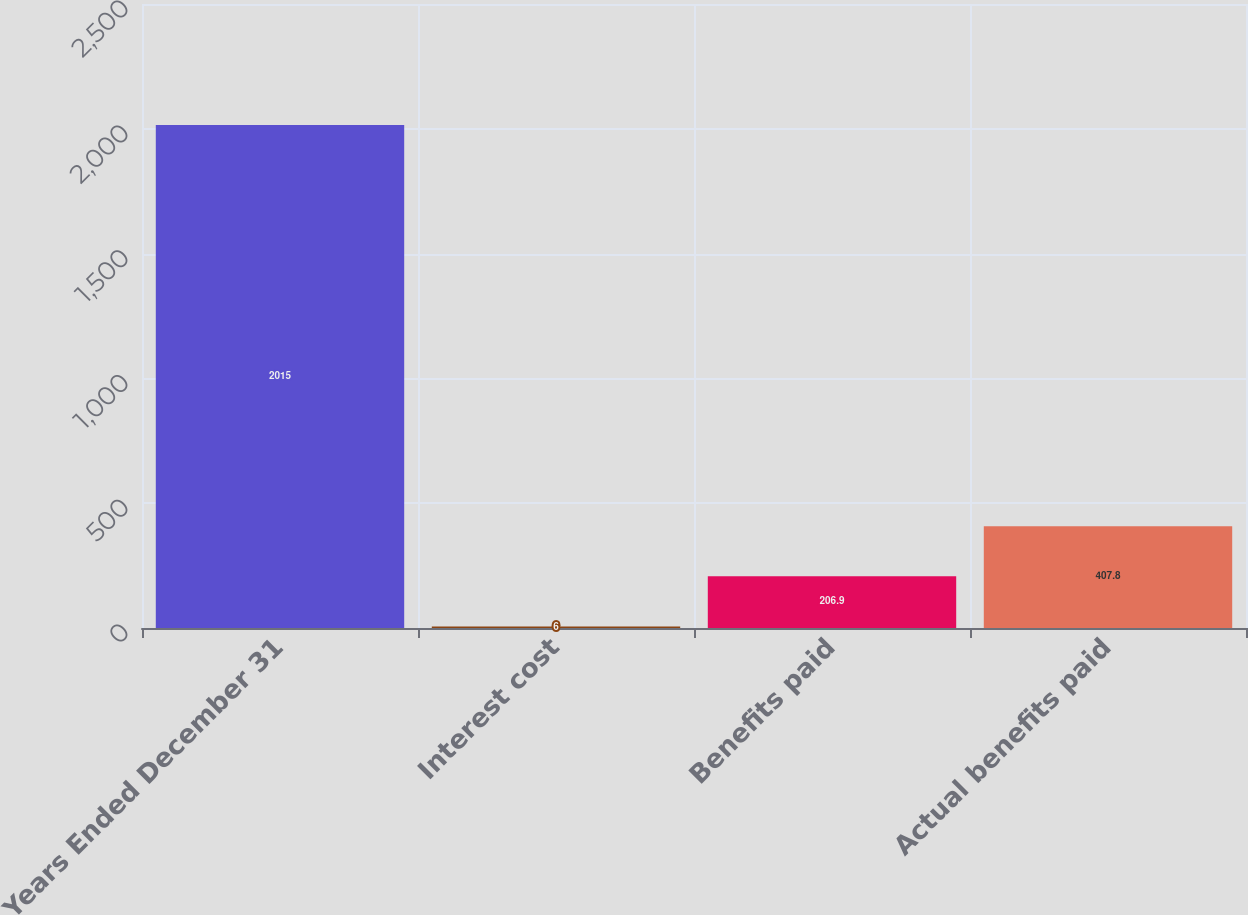<chart> <loc_0><loc_0><loc_500><loc_500><bar_chart><fcel>Years Ended December 31<fcel>Interest cost<fcel>Benefits paid<fcel>Actual benefits paid<nl><fcel>2015<fcel>6<fcel>206.9<fcel>407.8<nl></chart> 